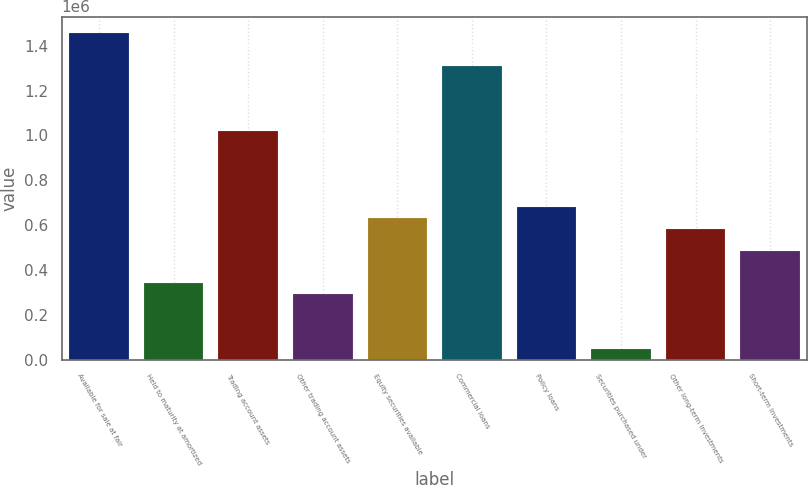<chart> <loc_0><loc_0><loc_500><loc_500><bar_chart><fcel>Available for sale at fair<fcel>Held to maturity at amortized<fcel>Trading account assets<fcel>Other trading account assets<fcel>Equity securities available<fcel>Commercial loans<fcel>Policy loans<fcel>Securities purchased under<fcel>Other long-term investments<fcel>Short-term investments<nl><fcel>1.45743e+06<fcel>340072<fcel>1.0202e+06<fcel>291491<fcel>631556<fcel>1.31169e+06<fcel>680137<fcel>48586.8<fcel>582976<fcel>485814<nl></chart> 